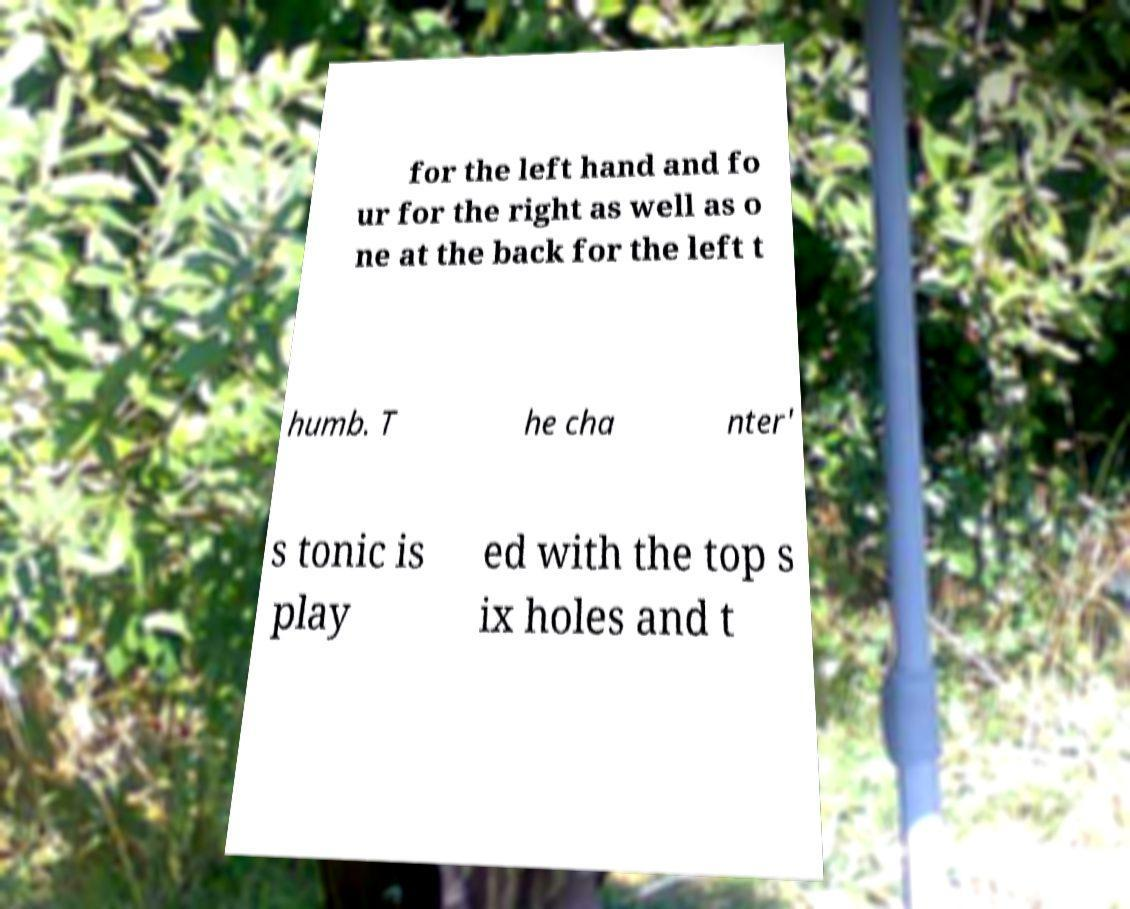Can you accurately transcribe the text from the provided image for me? for the left hand and fo ur for the right as well as o ne at the back for the left t humb. T he cha nter' s tonic is play ed with the top s ix holes and t 